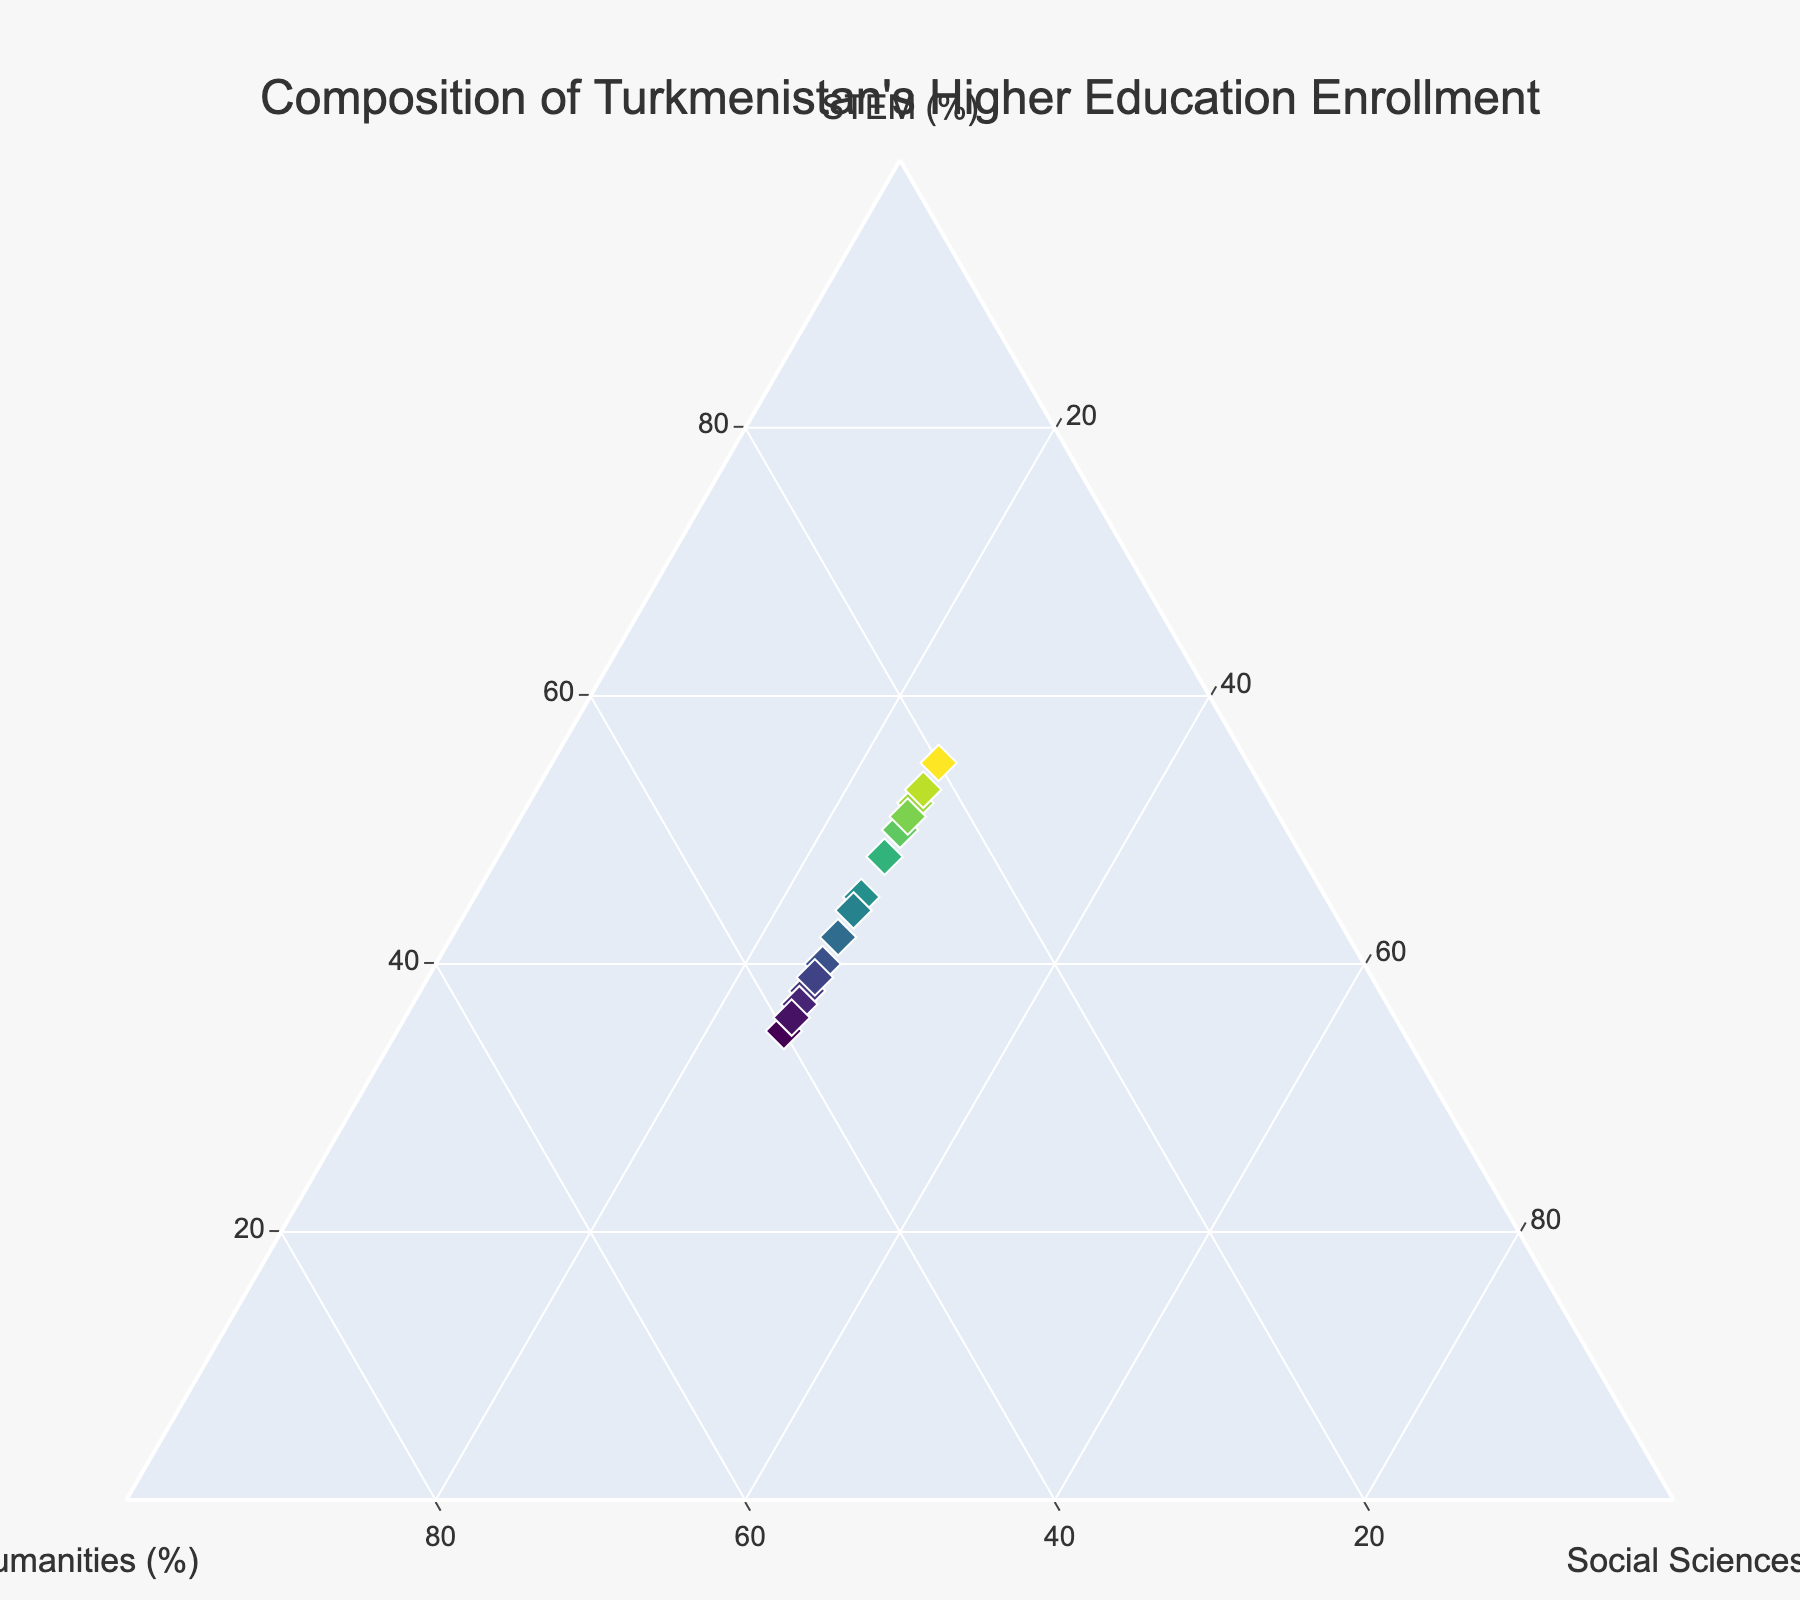How many data points are there in the plot? There are 15 rows of data representing 15 data points plotted on the ternary plot.
Answer: 15 What is the maximum percentage of STEM enrollment? By examining the ternary plot, the data point with the highest STEM percentage shows 55%.
Answer: 55% Which axis represents the humanities percentage? From the plot layout, the B-axis is labeled as 'Humanities (%)', representing the humanities percentage.
Answer: B-axis Are there any data points where the humanities percentage is exactly 25%? Yes, look for points where the humanities axis value (B-axis) is 25%. Two such data points exist where STEM is either 50% or 55%.
Answer: Yes What is the average value of STEM percentages? Sum up all STEM values and divide by the number of data points: (45 + 50 + 40 + 55 + 35 + 42 + 48 + 38 + 52 + 37 + 44 + 51 + 39 + 53 + 36) / 15. The total is 665, so the average is 44.33%.
Answer: 44.33% Compare the highest and lowest percentages of humanities. What is the difference? The highest humanities percentage is 40%, and the lowest is 20%. The difference is 40% - 20%, which equals 20%.
Answer: 20% What's the median value of humanities enrollment? Arrange all humanities values in ascending order: 20, 22, 23, 24, 25, 25, 25, 25, 27, 30, 31, 33, 35, 37, 38, 39, 40. The median value, being the 8th and 9th in the sorted list, is 25%.
Answer: 25% Identify a data point where STEM percentage is higher than both humanities and social sciences percentages. Points where STEM is greater than both, for example, 55% (STEM), 20% (Humanities), 25% (Social Sciences), meet this criterion.
Answer: 55% STEM, 20% Humanities, 25% Social Sciences Are there more data points where humanities proportion exceeds STEM proportion or vice-versa? Compare occurrences: Humanities > STEM happens at 35% (40 vs 35), 40% (40 vs 35), while STEM > Humanities happens at 45% (45 vs 30), 50% (50 vs 25), etc. More data points show STEM > Humanities.
Answer: More with STEM > Humanities 